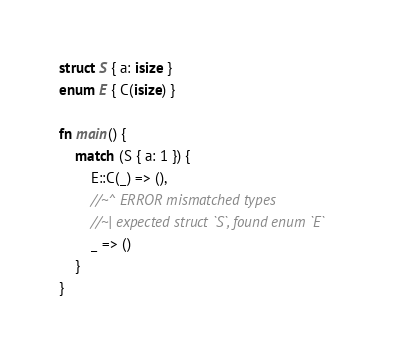Convert code to text. <code><loc_0><loc_0><loc_500><loc_500><_Rust_>struct S { a: isize }
enum E { C(isize) }

fn main() {
    match (S { a: 1 }) {
        E::C(_) => (),
        //~^ ERROR mismatched types
        //~| expected struct `S`, found enum `E`
        _ => ()
    }
}
</code> 